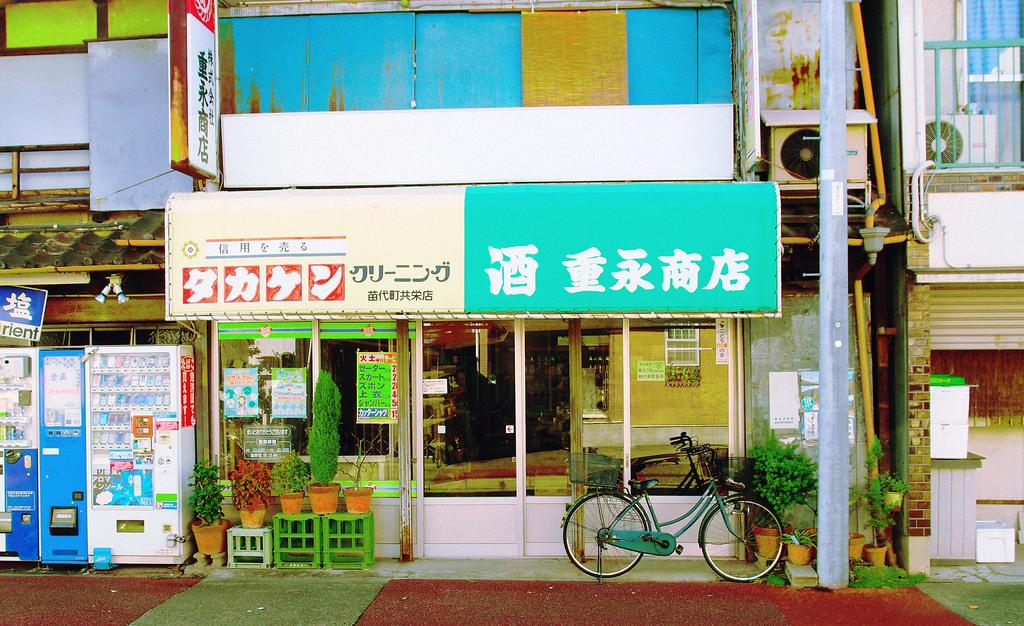What type of establishment is shown in the image? The image appears to depict a store. What can be seen near the store? There is a cycle parked in front of the store. What is located on the left side of the image? There are machines on the left side of the image. How many brothers are shown working in the store in the image? There is no information about brothers working in the store in the image. 